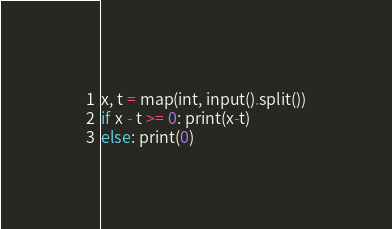Convert code to text. <code><loc_0><loc_0><loc_500><loc_500><_Python_>x, t = map(int, input().split())
if x - t >= 0: print(x-t)
else: print(0)</code> 